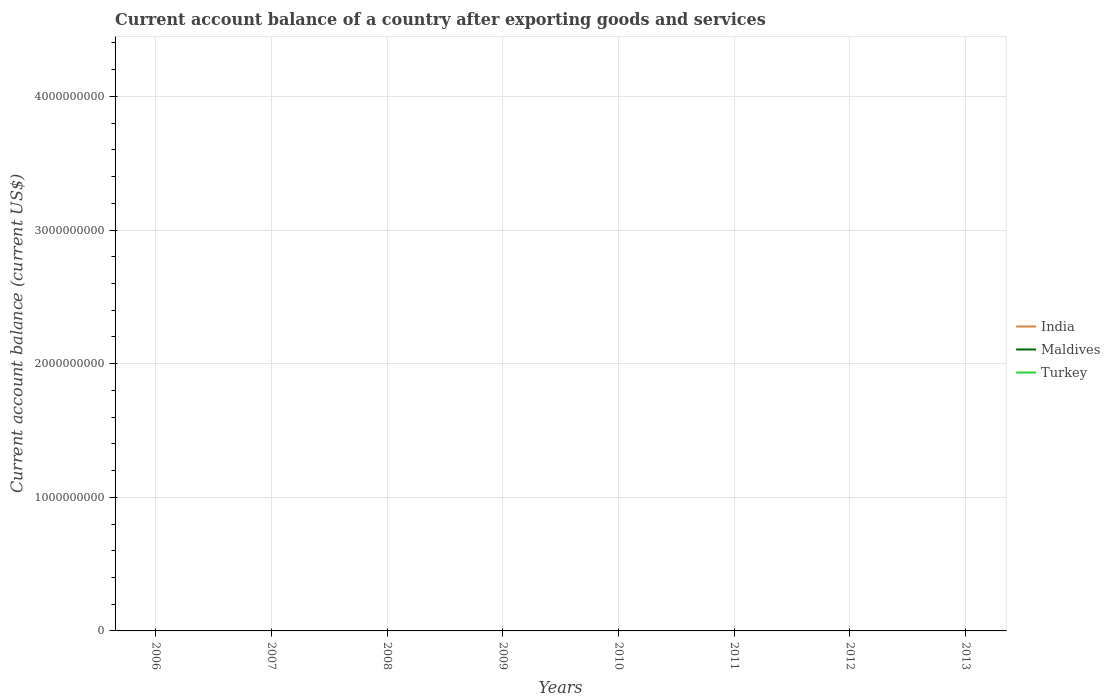How many different coloured lines are there?
Give a very brief answer. 0. What is the difference between the highest and the lowest account balance in India?
Ensure brevity in your answer.  0. How many lines are there?
Your response must be concise. 0. Are the values on the major ticks of Y-axis written in scientific E-notation?
Provide a short and direct response. No. Where does the legend appear in the graph?
Give a very brief answer. Center right. How many legend labels are there?
Give a very brief answer. 3. What is the title of the graph?
Provide a succinct answer. Current account balance of a country after exporting goods and services. What is the label or title of the X-axis?
Provide a short and direct response. Years. What is the label or title of the Y-axis?
Offer a terse response. Current account balance (current US$). What is the Current account balance (current US$) of India in 2006?
Your answer should be compact. 0. What is the Current account balance (current US$) of Maldives in 2006?
Offer a very short reply. 0. What is the Current account balance (current US$) in Turkey in 2006?
Provide a short and direct response. 0. What is the Current account balance (current US$) in India in 2007?
Keep it short and to the point. 0. What is the Current account balance (current US$) in Maldives in 2007?
Provide a succinct answer. 0. What is the Current account balance (current US$) in Turkey in 2007?
Offer a very short reply. 0. What is the Current account balance (current US$) of India in 2008?
Make the answer very short. 0. What is the Current account balance (current US$) of Turkey in 2008?
Give a very brief answer. 0. What is the Current account balance (current US$) of Maldives in 2009?
Your answer should be compact. 0. What is the Current account balance (current US$) in Maldives in 2010?
Give a very brief answer. 0. What is the Current account balance (current US$) in Turkey in 2010?
Your answer should be very brief. 0. What is the Current account balance (current US$) of India in 2011?
Offer a very short reply. 0. What is the Current account balance (current US$) in Maldives in 2011?
Offer a very short reply. 0. What is the Current account balance (current US$) of Turkey in 2011?
Offer a terse response. 0. What is the Current account balance (current US$) in India in 2012?
Make the answer very short. 0. What is the Current account balance (current US$) of Maldives in 2012?
Keep it short and to the point. 0. What is the Current account balance (current US$) in Turkey in 2012?
Offer a very short reply. 0. What is the Current account balance (current US$) in Maldives in 2013?
Your answer should be very brief. 0. What is the Current account balance (current US$) in Turkey in 2013?
Ensure brevity in your answer.  0. What is the total Current account balance (current US$) in Turkey in the graph?
Keep it short and to the point. 0. What is the average Current account balance (current US$) of Turkey per year?
Offer a terse response. 0. 